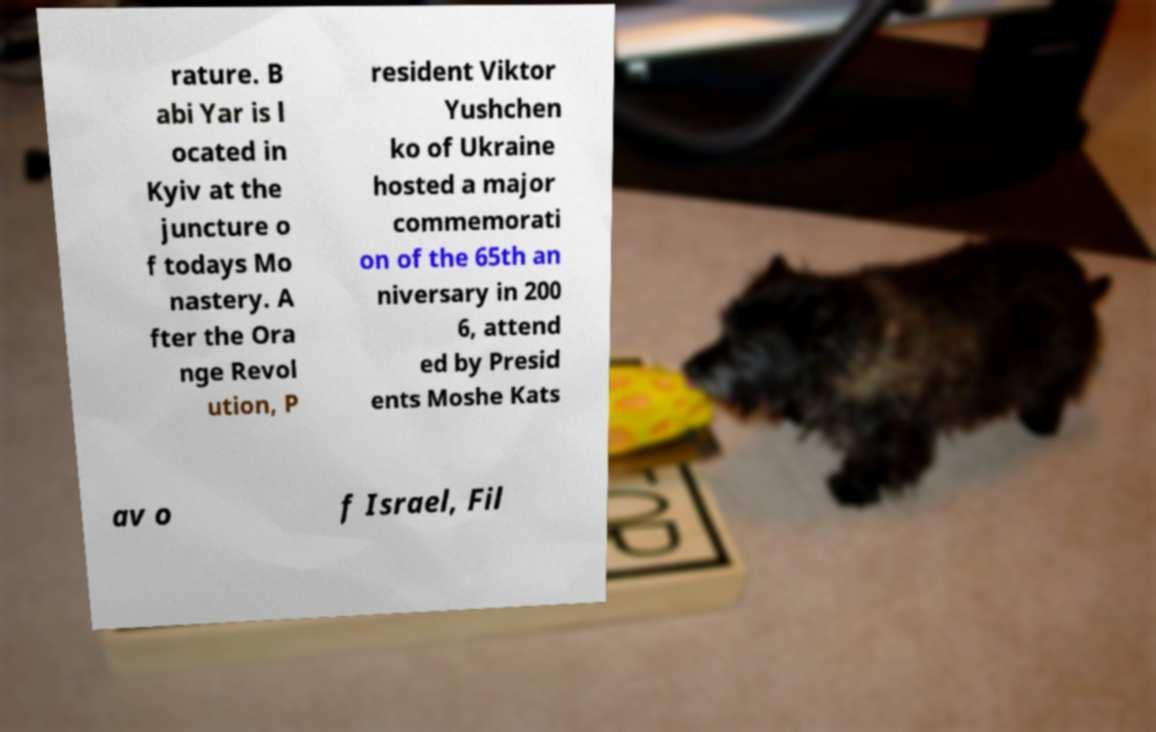Please read and relay the text visible in this image. What does it say? rature. B abi Yar is l ocated in Kyiv at the juncture o f todays Mo nastery. A fter the Ora nge Revol ution, P resident Viktor Yushchen ko of Ukraine hosted a major commemorati on of the 65th an niversary in 200 6, attend ed by Presid ents Moshe Kats av o f Israel, Fil 